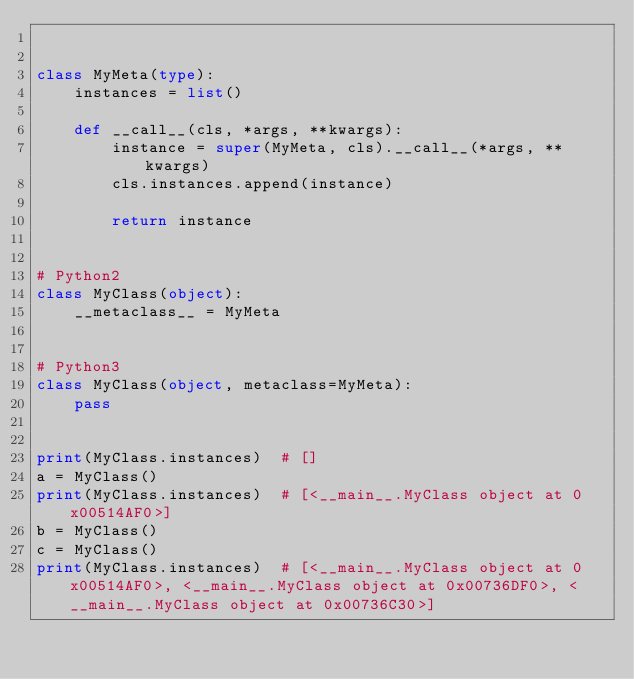<code> <loc_0><loc_0><loc_500><loc_500><_Python_>

class MyMeta(type):
    instances = list()

    def __call__(cls, *args, **kwargs):
        instance = super(MyMeta, cls).__call__(*args, **kwargs)
        cls.instances.append(instance)

        return instance


# Python2
class MyClass(object):
    __metaclass__ = MyMeta


# Python3
class MyClass(object, metaclass=MyMeta):
    pass


print(MyClass.instances)  # []
a = MyClass()
print(MyClass.instances)  # [<__main__.MyClass object at 0x00514AF0>]
b = MyClass()
c = MyClass()
print(MyClass.instances)  # [<__main__.MyClass object at 0x00514AF0>, <__main__.MyClass object at 0x00736DF0>, <__main__.MyClass object at 0x00736C30>]
</code> 